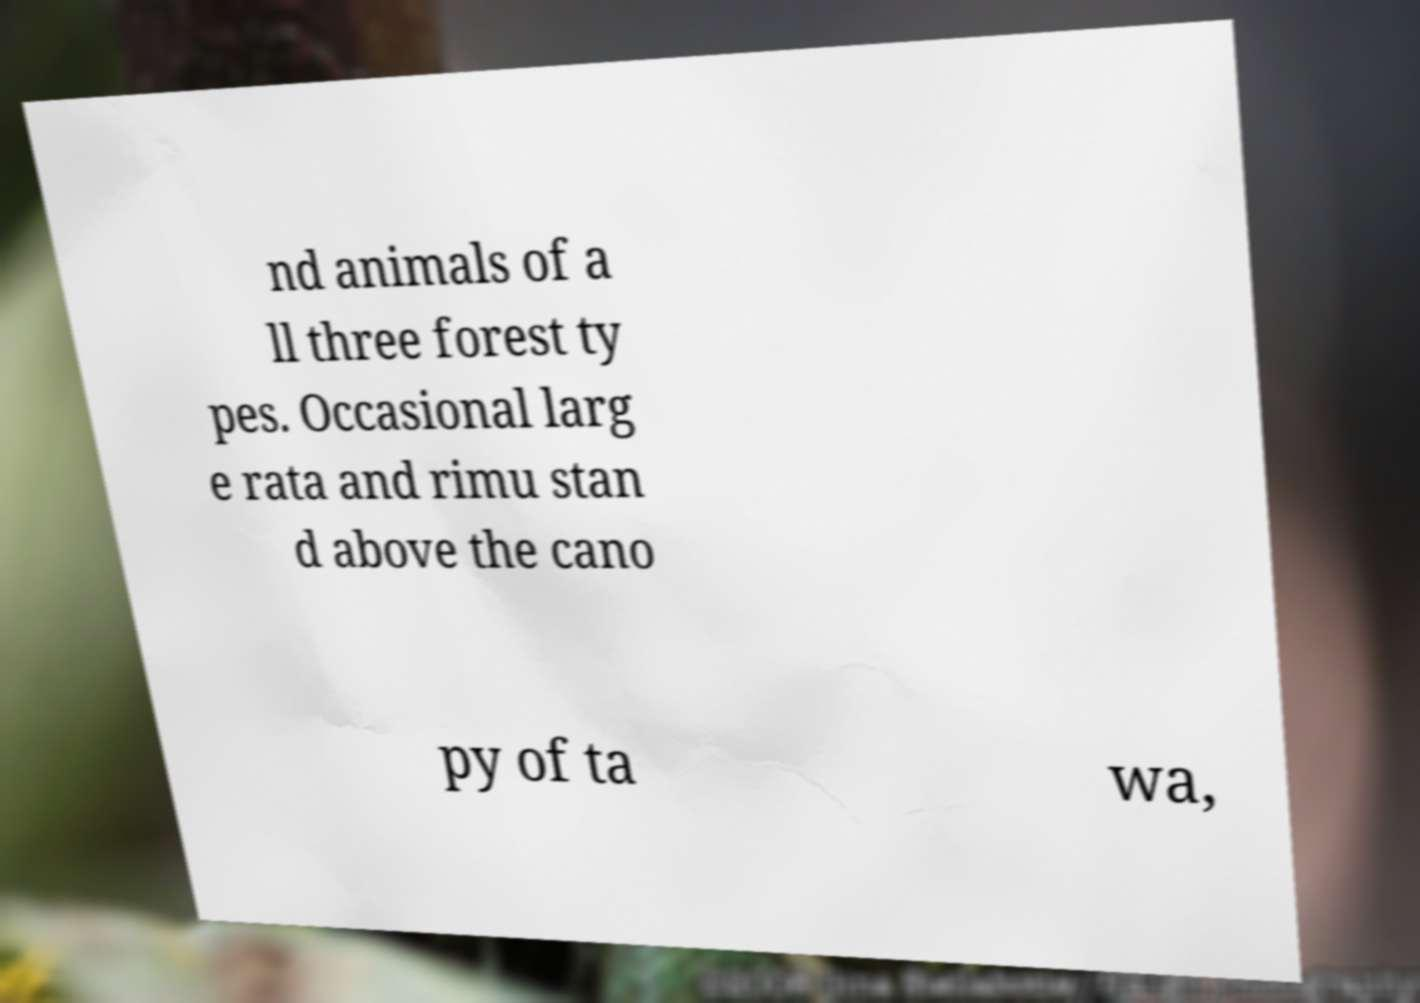Please read and relay the text visible in this image. What does it say? nd animals of a ll three forest ty pes. Occasional larg e rata and rimu stan d above the cano py of ta wa, 